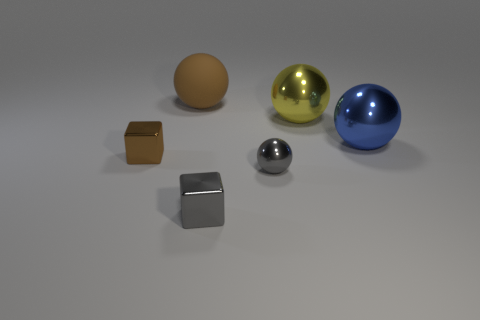What do the objects tell you about the possible purpose of the image? The image could be for a variety of purposes. It might be a rendering to demonstrate different materials and reflective properties in a 3D modeling program, where light and shadows play significant roles. Alternatively, it could be an art composition, focusing on symmetry and balance among the different shapes and colors. Without more context, it's difficult to ascertain the exact purpose, but it's clear that the image is designed to showcase contrasts in shape, size, and texture. 